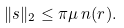Convert formula to latex. <formula><loc_0><loc_0><loc_500><loc_500>\| s \| _ { 2 } \leq \pi \mu \, n ( r ) .</formula> 